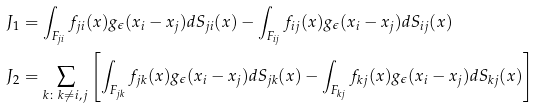<formula> <loc_0><loc_0><loc_500><loc_500>J _ { 1 } & = \int _ { F _ { j i } } f _ { j i } ( x ) g _ { \epsilon } ( x _ { i } - x _ { j } ) d S _ { j i } ( x ) - \int _ { F _ { i j } } f _ { i j } ( x ) g _ { \epsilon } ( x _ { i } - x _ { j } ) d S _ { i j } ( x ) \\ J _ { 2 } & = \sum _ { k \colon k \neq i , \, j } \left [ \int _ { F _ { j k } } f _ { j k } ( x ) g _ { \epsilon } ( x _ { i } - x _ { j } ) d S _ { j k } ( x ) - \int _ { F _ { k j } } f _ { k j } ( x ) g _ { \epsilon } ( x _ { i } - x _ { j } ) d S _ { k j } ( x ) \right ]</formula> 